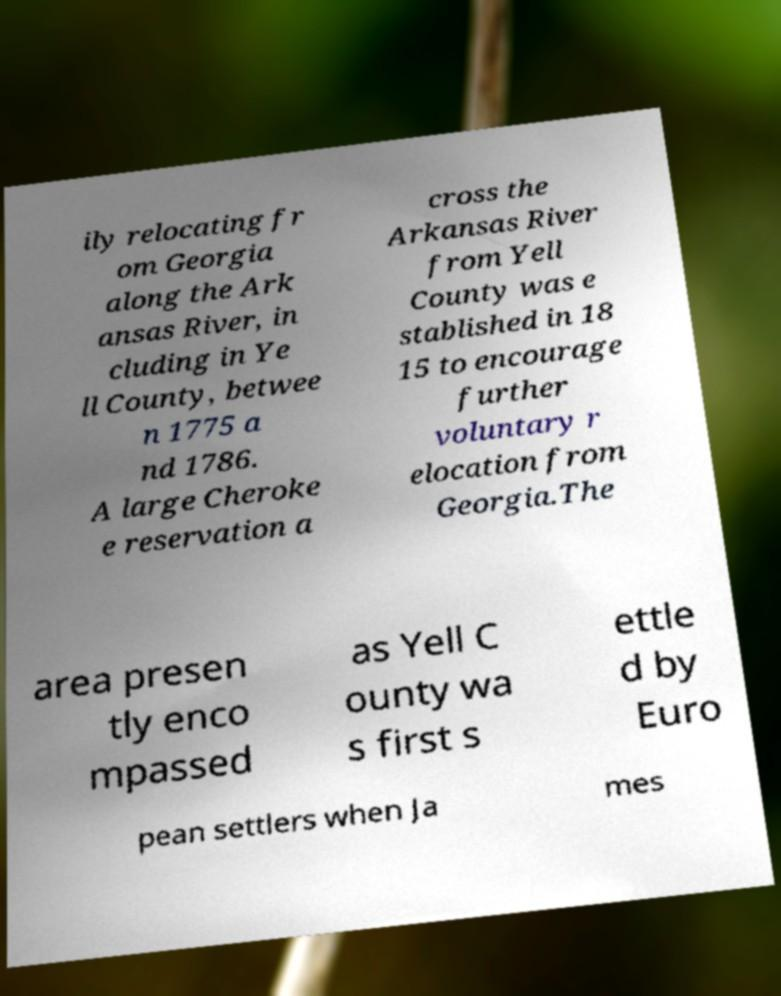I need the written content from this picture converted into text. Can you do that? ily relocating fr om Georgia along the Ark ansas River, in cluding in Ye ll County, betwee n 1775 a nd 1786. A large Cheroke e reservation a cross the Arkansas River from Yell County was e stablished in 18 15 to encourage further voluntary r elocation from Georgia.The area presen tly enco mpassed as Yell C ounty wa s first s ettle d by Euro pean settlers when Ja mes 